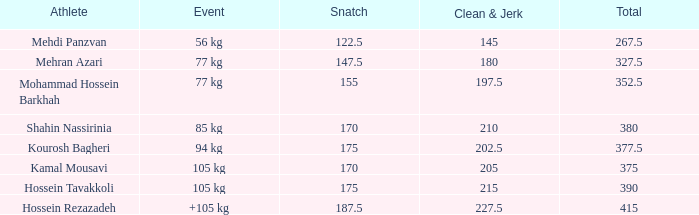What is the minimum sum that had fewer than 170 snatches, 56 kg events, and under 145 clean & jerk? None. 